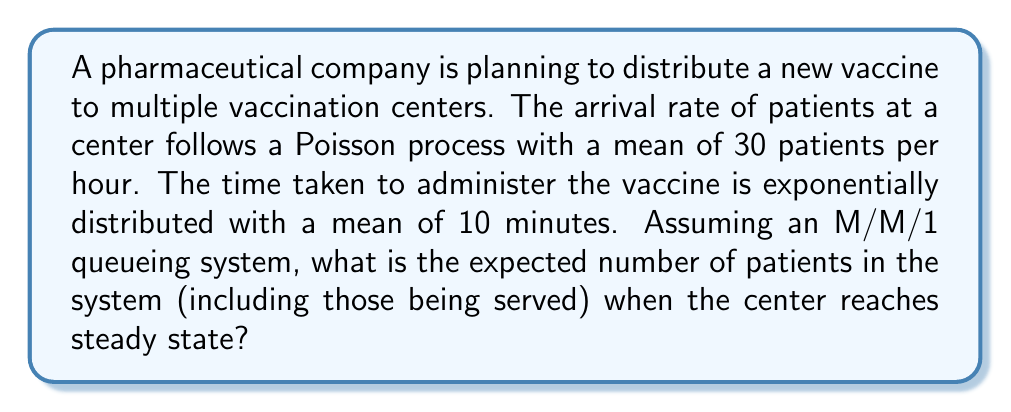Teach me how to tackle this problem. To solve this problem, we'll use the M/M/1 queueing theory model. Let's break it down step-by-step:

1. Identify the given parameters:
   - Arrival rate: $\lambda = 30$ patients/hour
   - Service rate: $\mu = 6$ patients/hour (since 1 hour = 60 minutes, and mean service time is 10 minutes)

2. Calculate the traffic intensity $\rho$:
   $$\rho = \frac{\lambda}{\mu} = \frac{30}{6} = 5$$

3. Check for system stability:
   For a stable system, we need $\rho < 1$. In this case, $\rho = 5 > 1$, indicating an unstable system.

4. Despite the instability, we can still calculate the expected number of patients in the system using the formula for M/M/1 queues:
   $$L = \frac{\rho}{1-\rho}$$

5. Substitute the value of $\rho$:
   $$L = \frac{5}{1-5} = \frac{5}{-4} = -1.25$$

6. Interpret the result:
   The negative value indicates that the system is overloaded and cannot reach a steady state. In practice, this means the queue will grow indefinitely, and the center cannot handle the incoming patient flow with the current setup.
Answer: The system is unstable and cannot reach steady state. 